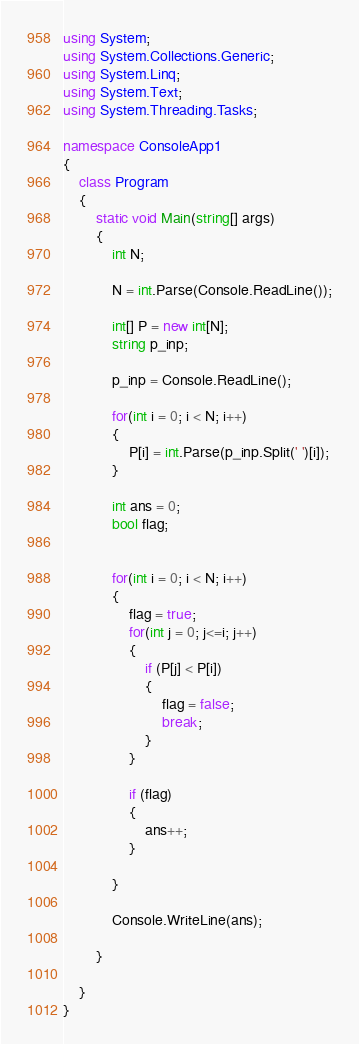Convert code to text. <code><loc_0><loc_0><loc_500><loc_500><_C#_>using System;
using System.Collections.Generic;
using System.Linq;
using System.Text;
using System.Threading.Tasks;

namespace ConsoleApp1
{
    class Program
    {
        static void Main(string[] args)
        {
            int N;

            N = int.Parse(Console.ReadLine());

            int[] P = new int[N];
            string p_inp;

            p_inp = Console.ReadLine();

            for(int i = 0; i < N; i++)
            {
                P[i] = int.Parse(p_inp.Split(' ')[i]);
            }

            int ans = 0;
            bool flag;

    
            for(int i = 0; i < N; i++)
            {
                flag = true;
                for(int j = 0; j<=i; j++)
                {
                    if (P[j] < P[i])
                    {
                        flag = false;
                        break;
                    }
                }

                if (flag)
                {
                    ans++;
                }
      
            }

            Console.WriteLine(ans);

        }

    }
}
</code> 